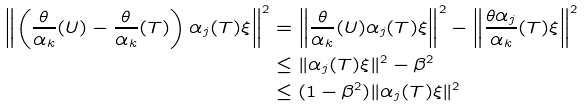Convert formula to latex. <formula><loc_0><loc_0><loc_500><loc_500>\left \| \left ( \frac { \theta } { \alpha _ { k } } ( U ) - \frac { \theta } { \alpha _ { k } } ( T ) \right ) \alpha _ { j } ( T ) \xi \right \| ^ { 2 } & = \left \| \frac { \theta } { \alpha _ { k } } ( U ) \alpha _ { j } ( T ) \xi \right \| ^ { 2 } - \left \| \frac { \theta \alpha _ { j } } { \alpha _ { k } } ( T ) \xi \right \| ^ { 2 } \\ & \leq \| \alpha _ { j } ( T ) \xi \| ^ { 2 } - \beta ^ { 2 } \\ & \leq ( 1 - \beta ^ { 2 } ) \| \alpha _ { j } ( T ) \xi \| ^ { 2 }</formula> 